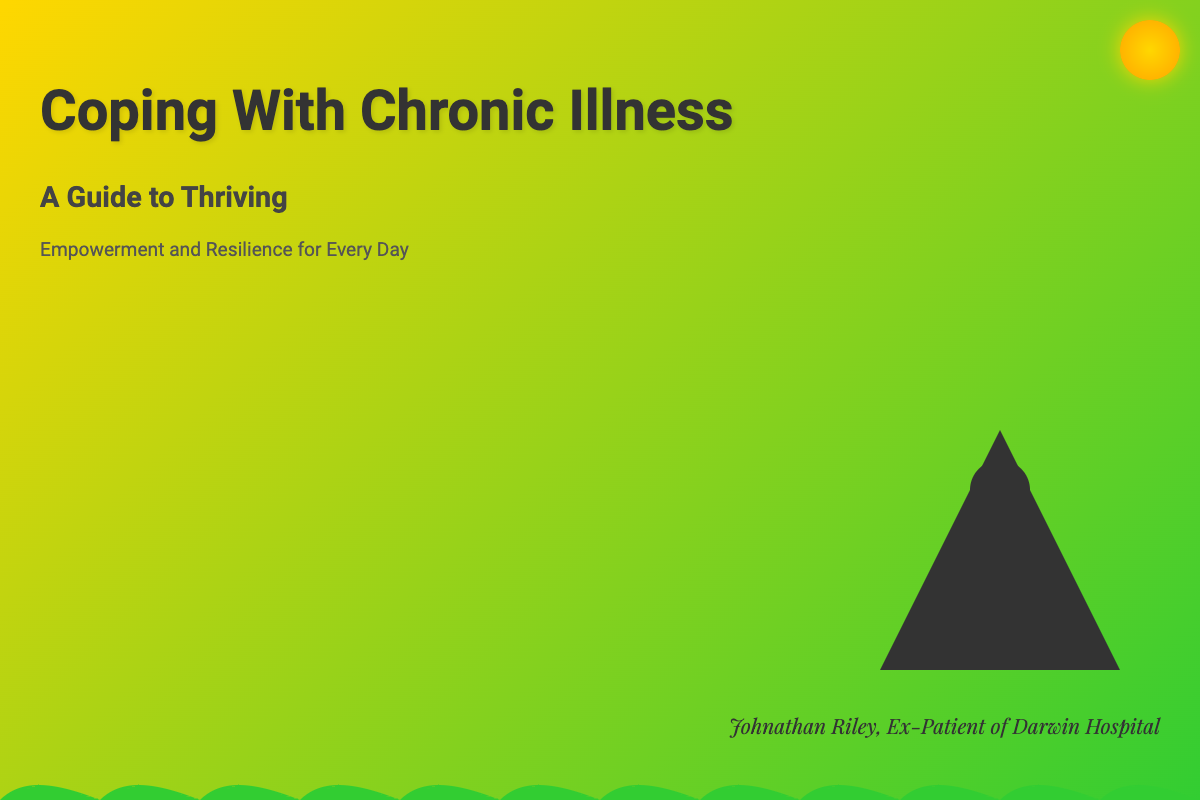what is the title of the book? The title is prominently displayed in large text at the top of the cover.
Answer: Coping With Chronic Illness what is the subtitle of the book? The subtitle is shown directly below the title on the cover.
Answer: A Guide to Thriving who is the author of the book? The author's name is mentioned at the bottom of the cover.
Answer: Johnathan Riley what colors are primarily used in the cover design? The colors used in the gradient background feature prominently on the cover.
Answer: Yellow and green what is the tagline of the book? The tagline is positioned under the subtitle and conveys the book's purpose.
Answer: Empowerment and Resilience for Every Day how many figures are depicted on the cover? There is a specific element displayed that represents a figure overcoming obstacles.
Answer: One figure what element is depicted in the top right corner? The design includes additional elements that can enhance the cover's theme.
Answer: Sun what does the cover design aim to convey? The overall design and visuals are intended to communicate a certain theme or feeling.
Answer: Thriving and overcoming obstacles 